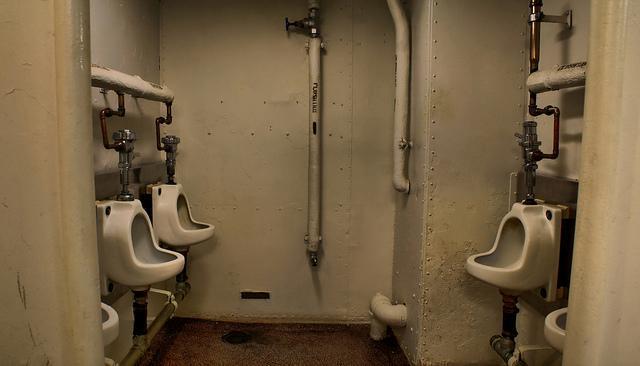How many toilets are there?
Give a very brief answer. 3. How many of the trucks doors are open?
Give a very brief answer. 0. 